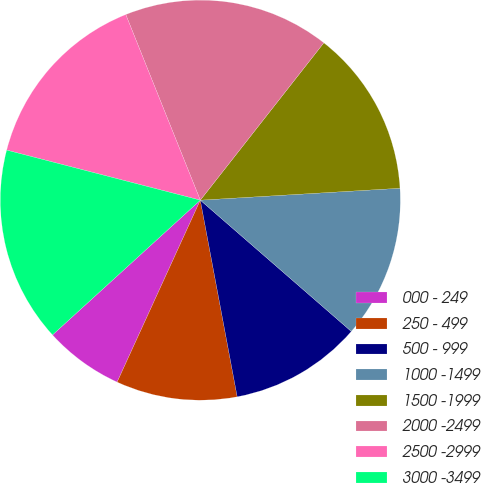Convert chart to OTSL. <chart><loc_0><loc_0><loc_500><loc_500><pie_chart><fcel>000 - 249<fcel>250 - 499<fcel>500 - 999<fcel>1000 -1499<fcel>1500 -1999<fcel>2000 -2499<fcel>2500 -2999<fcel>3000 -3499<nl><fcel>6.41%<fcel>9.78%<fcel>10.66%<fcel>12.34%<fcel>13.46%<fcel>16.67%<fcel>14.9%<fcel>15.79%<nl></chart> 